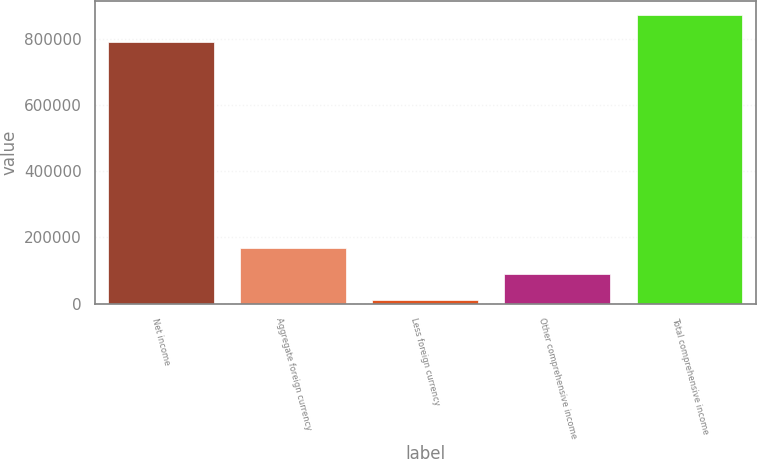Convert chart. <chart><loc_0><loc_0><loc_500><loc_500><bar_chart><fcel>Net income<fcel>Aggregate foreign currency<fcel>Less foreign currency<fcel>Other comprehensive income<fcel>Total comprehensive income<nl><fcel>790456<fcel>169207<fcel>9662<fcel>89434.3<fcel>870228<nl></chart> 